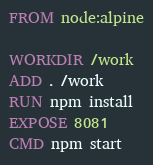<code> <loc_0><loc_0><loc_500><loc_500><_Dockerfile_>FROM node:alpine

WORKDIR /work
ADD . /work
RUN npm install
EXPOSE 8081
CMD npm start


</code> 